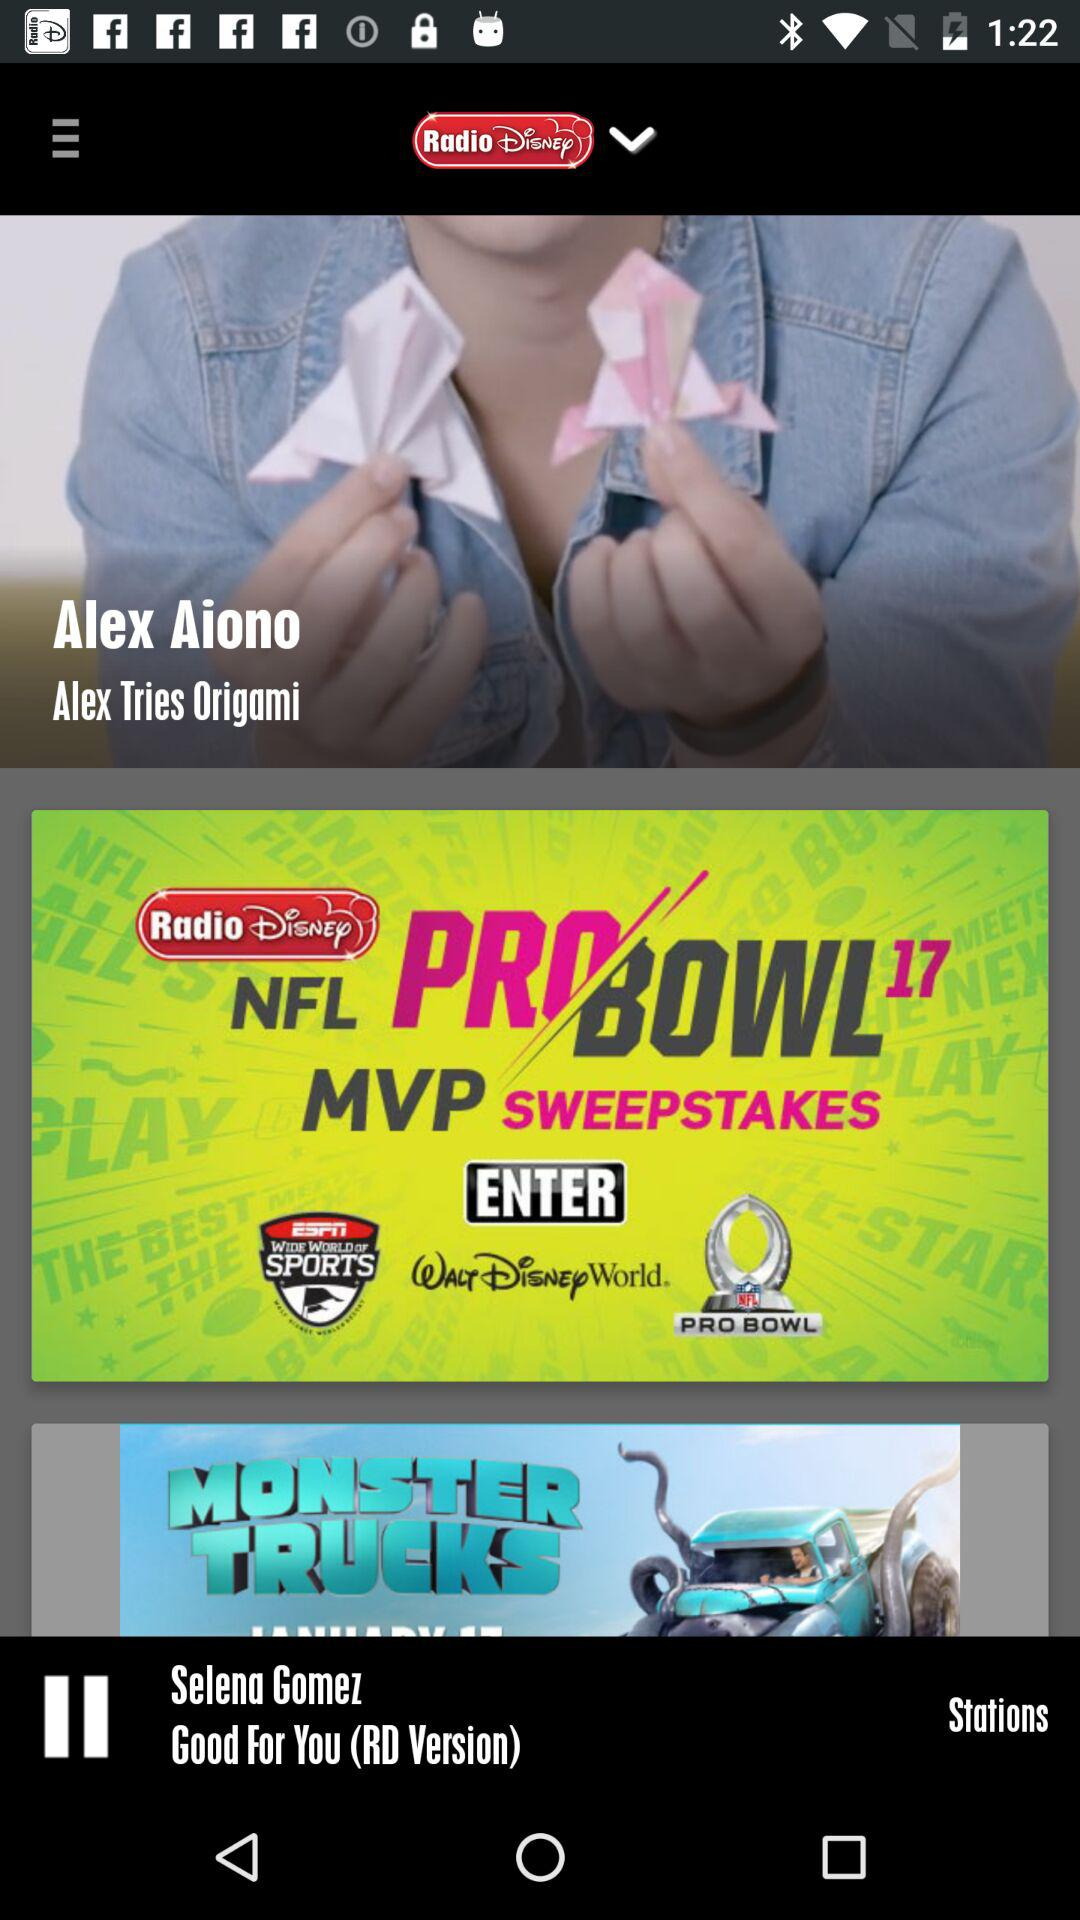What version is it? The version is RD. 